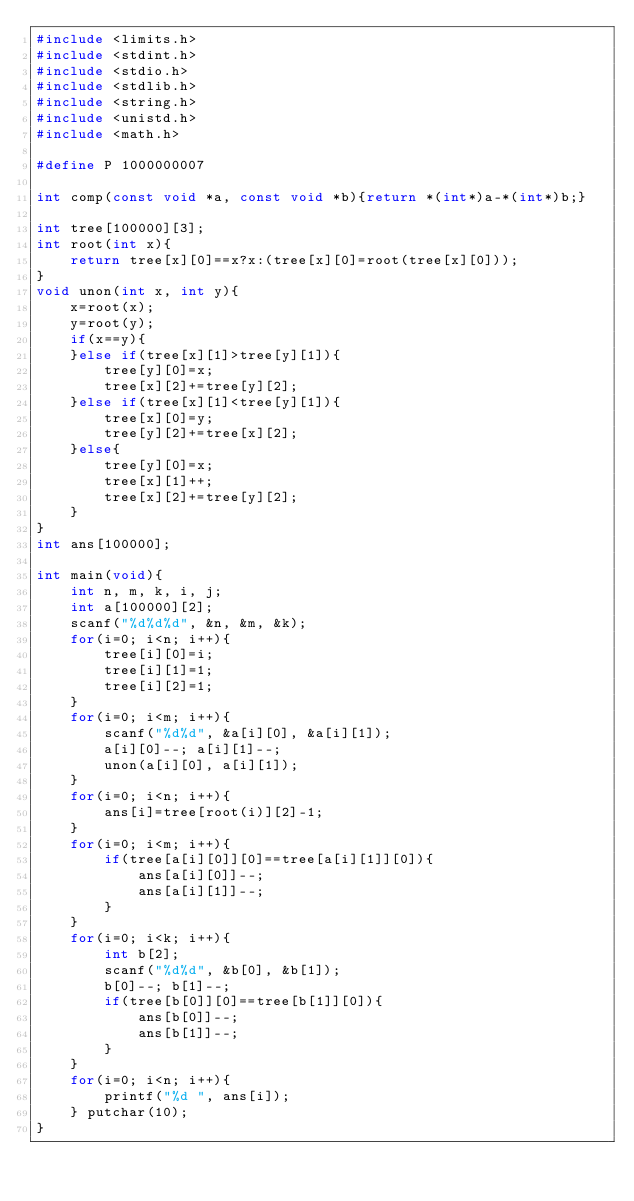Convert code to text. <code><loc_0><loc_0><loc_500><loc_500><_C_>#include <limits.h>
#include <stdint.h>
#include <stdio.h>
#include <stdlib.h>
#include <string.h>
#include <unistd.h>
#include <math.h>

#define P 1000000007

int comp(const void *a, const void *b){return *(int*)a-*(int*)b;}

int tree[100000][3];
int root(int x){
	return tree[x][0]==x?x:(tree[x][0]=root(tree[x][0]));
}
void unon(int x, int y){
	x=root(x);
	y=root(y);
	if(x==y){
	}else if(tree[x][1]>tree[y][1]){
		tree[y][0]=x;
		tree[x][2]+=tree[y][2];
	}else if(tree[x][1]<tree[y][1]){
		tree[x][0]=y;
		tree[y][2]+=tree[x][2];
	}else{
		tree[y][0]=x;
		tree[x][1]++;
		tree[x][2]+=tree[y][2];
	}
}
int ans[100000];

int main(void){
	int n, m, k, i, j;
	int a[100000][2];
	scanf("%d%d%d", &n, &m, &k);
	for(i=0; i<n; i++){
		tree[i][0]=i;
		tree[i][1]=1;
		tree[i][2]=1;
	}
	for(i=0; i<m; i++){
		scanf("%d%d", &a[i][0], &a[i][1]);
		a[i][0]--; a[i][1]--;
		unon(a[i][0], a[i][1]);
	}
	for(i=0; i<n; i++){
		ans[i]=tree[root(i)][2]-1;
	}
	for(i=0; i<m; i++){
		if(tree[a[i][0]][0]==tree[a[i][1]][0]){
			ans[a[i][0]]--;
			ans[a[i][1]]--;
		}
	}
	for(i=0; i<k; i++){
		int b[2];
		scanf("%d%d", &b[0], &b[1]);
		b[0]--; b[1]--;
		if(tree[b[0]][0]==tree[b[1]][0]){
			ans[b[0]]--;
			ans[b[1]]--;
		}
	}
	for(i=0; i<n; i++){
		printf("%d ", ans[i]);
	} putchar(10);
}
</code> 